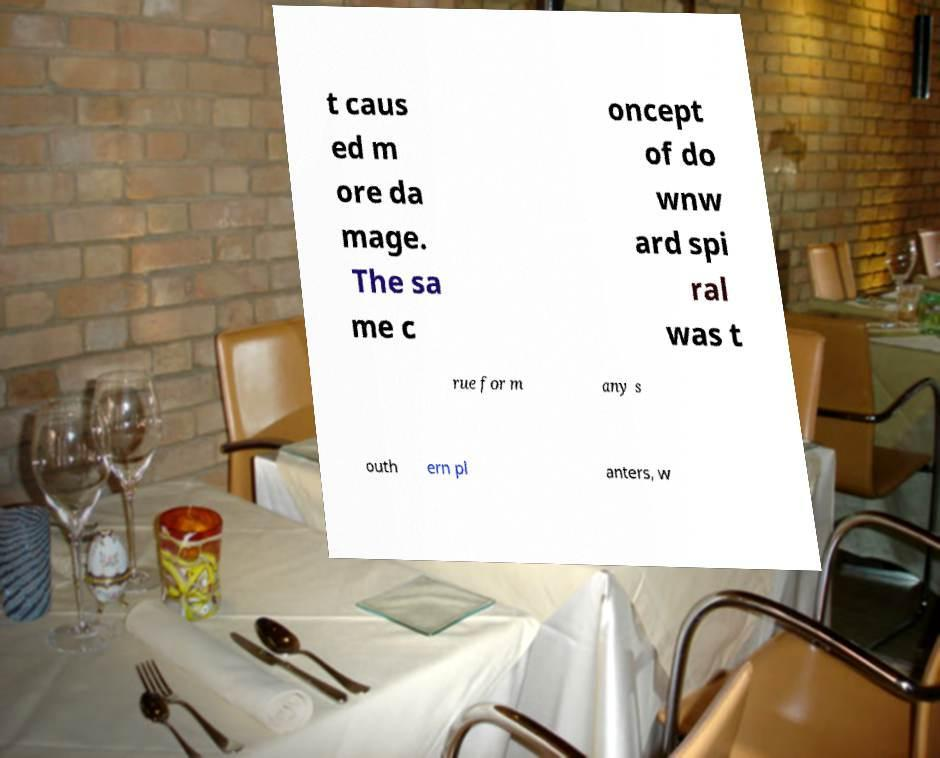Please identify and transcribe the text found in this image. t caus ed m ore da mage. The sa me c oncept of do wnw ard spi ral was t rue for m any s outh ern pl anters, w 